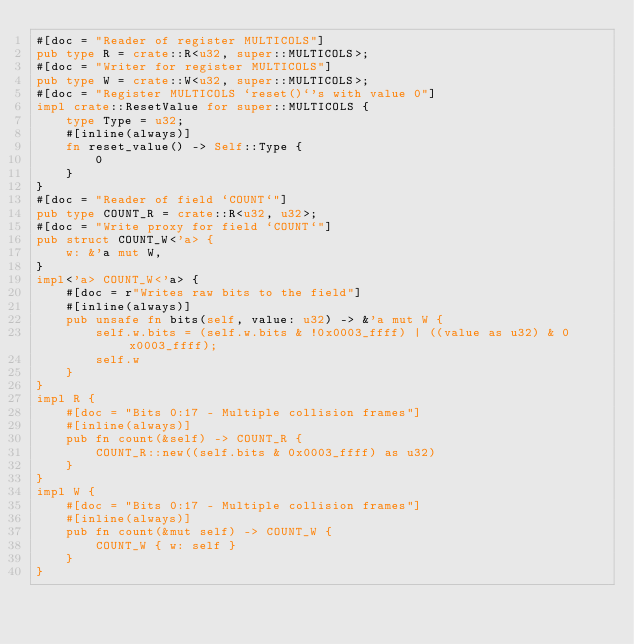Convert code to text. <code><loc_0><loc_0><loc_500><loc_500><_Rust_>#[doc = "Reader of register MULTICOLS"]
pub type R = crate::R<u32, super::MULTICOLS>;
#[doc = "Writer for register MULTICOLS"]
pub type W = crate::W<u32, super::MULTICOLS>;
#[doc = "Register MULTICOLS `reset()`'s with value 0"]
impl crate::ResetValue for super::MULTICOLS {
    type Type = u32;
    #[inline(always)]
    fn reset_value() -> Self::Type {
        0
    }
}
#[doc = "Reader of field `COUNT`"]
pub type COUNT_R = crate::R<u32, u32>;
#[doc = "Write proxy for field `COUNT`"]
pub struct COUNT_W<'a> {
    w: &'a mut W,
}
impl<'a> COUNT_W<'a> {
    #[doc = r"Writes raw bits to the field"]
    #[inline(always)]
    pub unsafe fn bits(self, value: u32) -> &'a mut W {
        self.w.bits = (self.w.bits & !0x0003_ffff) | ((value as u32) & 0x0003_ffff);
        self.w
    }
}
impl R {
    #[doc = "Bits 0:17 - Multiple collision frames"]
    #[inline(always)]
    pub fn count(&self) -> COUNT_R {
        COUNT_R::new((self.bits & 0x0003_ffff) as u32)
    }
}
impl W {
    #[doc = "Bits 0:17 - Multiple collision frames"]
    #[inline(always)]
    pub fn count(&mut self) -> COUNT_W {
        COUNT_W { w: self }
    }
}
</code> 